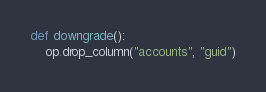<code> <loc_0><loc_0><loc_500><loc_500><_Python_>

def downgrade():
    op.drop_column("accounts", "guid")
</code> 